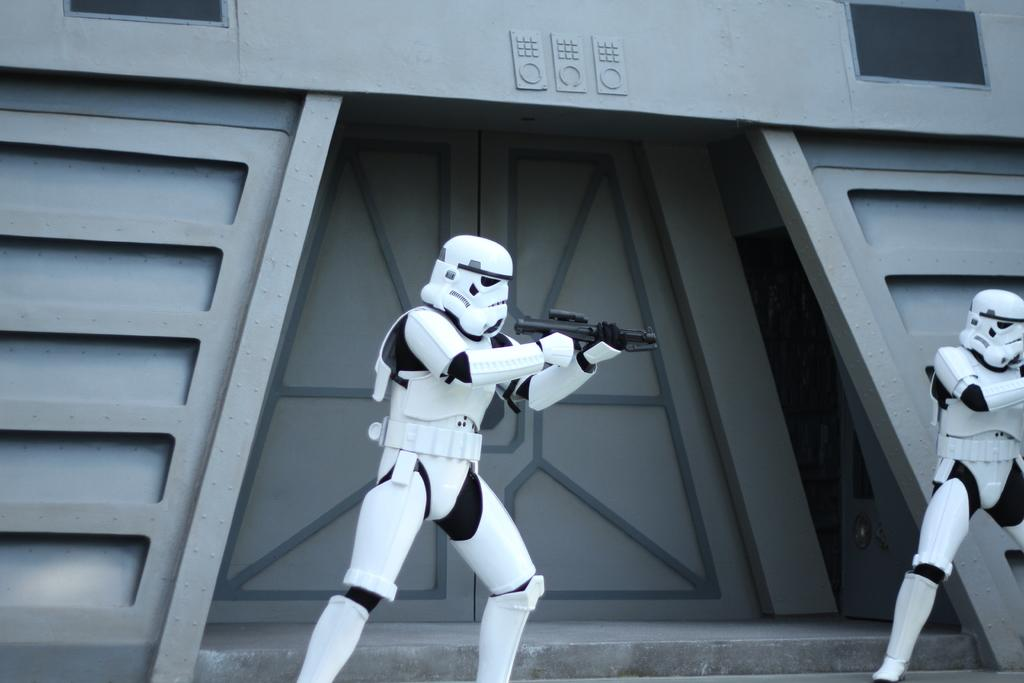How many robots are present in the image? There are two robots in the image. What are the robots holding in their hands? The robots are holding guns. What can be seen in the background of the image? There is a building in the background of the image. Can you describe the entrance of the building? The building has an entrance in the middle. What type of brain can be seen in the image? There is no brain present in the image; it features two robots holding guns and a building in the background. 